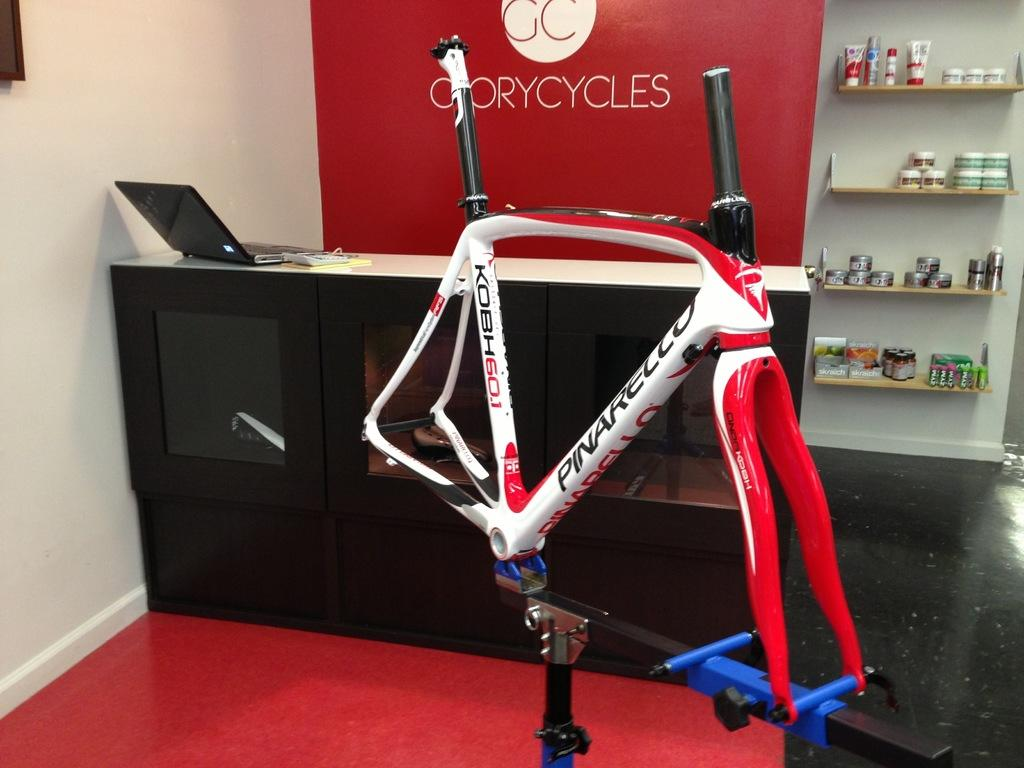<image>
Relay a brief, clear account of the picture shown. A cycling machine in the middle of the room with a sign that says Gorycycles 